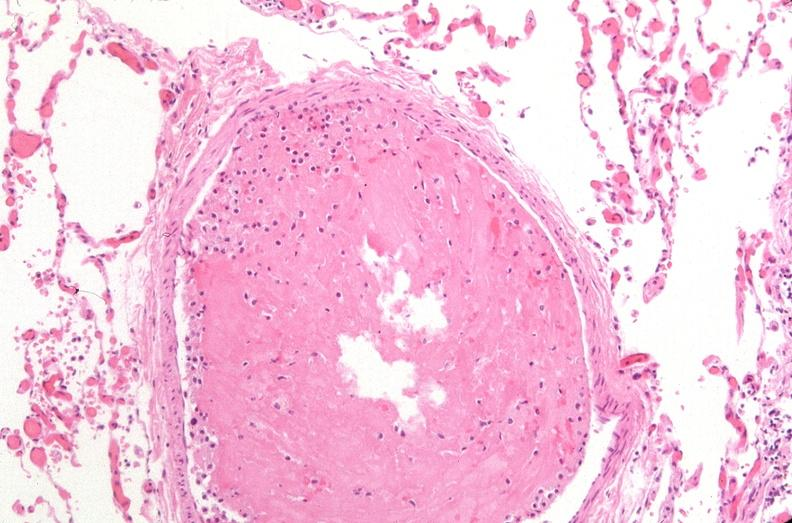what does this image show?
Answer the question using a single word or phrase. Lung 